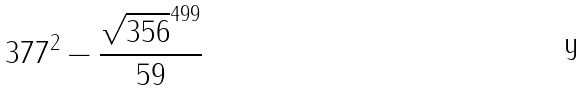<formula> <loc_0><loc_0><loc_500><loc_500>3 7 7 ^ { 2 } - \frac { \sqrt { 3 5 6 } ^ { 4 9 9 } } { 5 9 }</formula> 